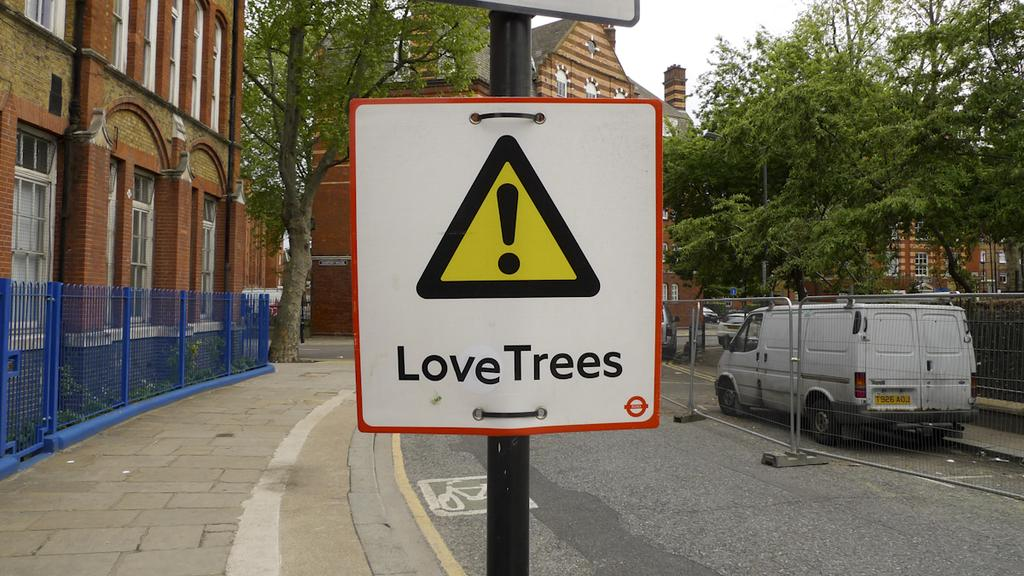<image>
Offer a succinct explanation of the picture presented. A triangular caution sign that says Love Trees on it. 